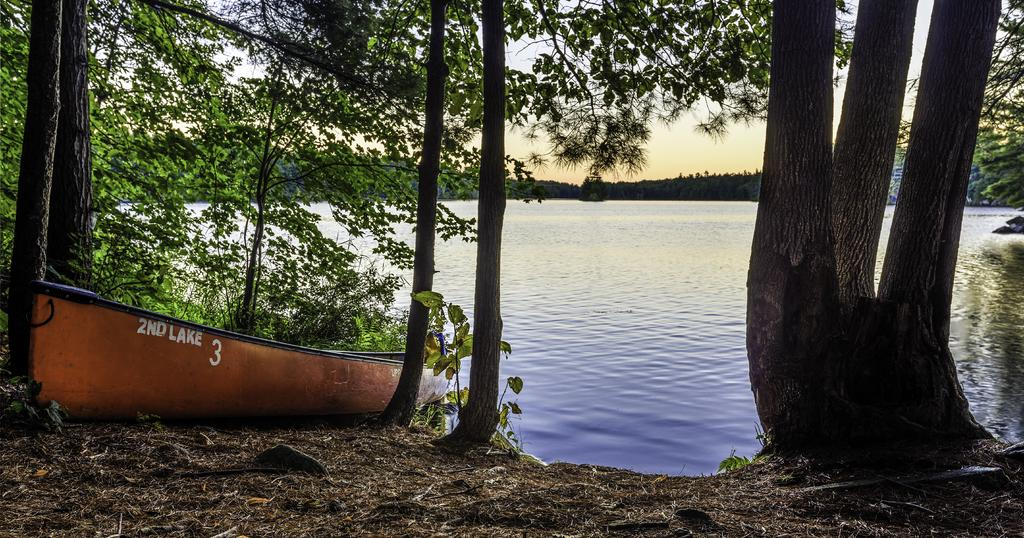What object is located on the left side of the image? There is a boat on the ground on the left side of the image. What is the boat's proximity to other objects in the image? The boat is near trees. What type of vegetation is on the right side of the image? There are trees on the right side of the image. What can be seen in the background of the image? Water, trees, and the sky are visible in the background of the image. What type of apparatus is being used to catch insects in the image? There is no apparatus or insects present in the image. What type of ship is visible in the background of the image? There is no ship visible in the image; only a boat and trees are present. 